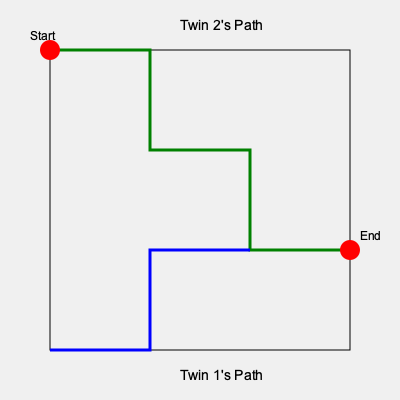In this magical forest maze, two twins start their journey together but take different paths. Twin 1 follows the blue path, while Twin 2 follows the green path. At which point in the maze do the twins' paths intersect, allowing them to reunite before reaching the end together? To determine where the twins' paths intersect, we need to follow their routes through the maze:

1. Both twins start at the top-left corner (50,50).
2. Twin 1 (blue path):
   - Moves down to (50,350)
   - Moves right to (150,350)
   - Moves up to (150,250)
   - Moves right to (250,250)
3. Twin 2 (green path):
   - Moves right to (150,50)
   - Moves down to (150,150)
   - Moves right to (250,150)
   - Moves down to (250,250)
4. The paths intersect at the point (250,250).
5. From there, both twins move together to the end point (350,250).

The intersection point (250,250) represents the moment in the story where the twins reunite after their separate adventures in the magical forest.
Answer: (250,250) 